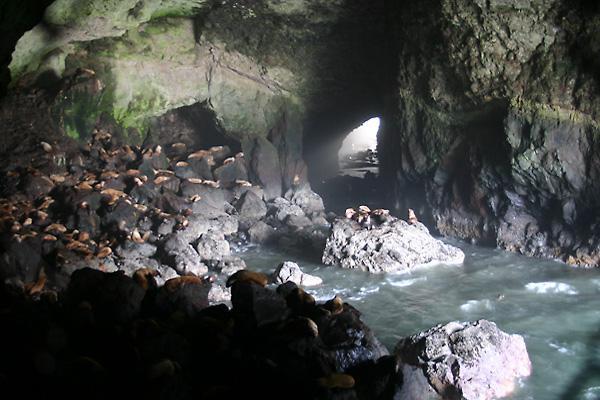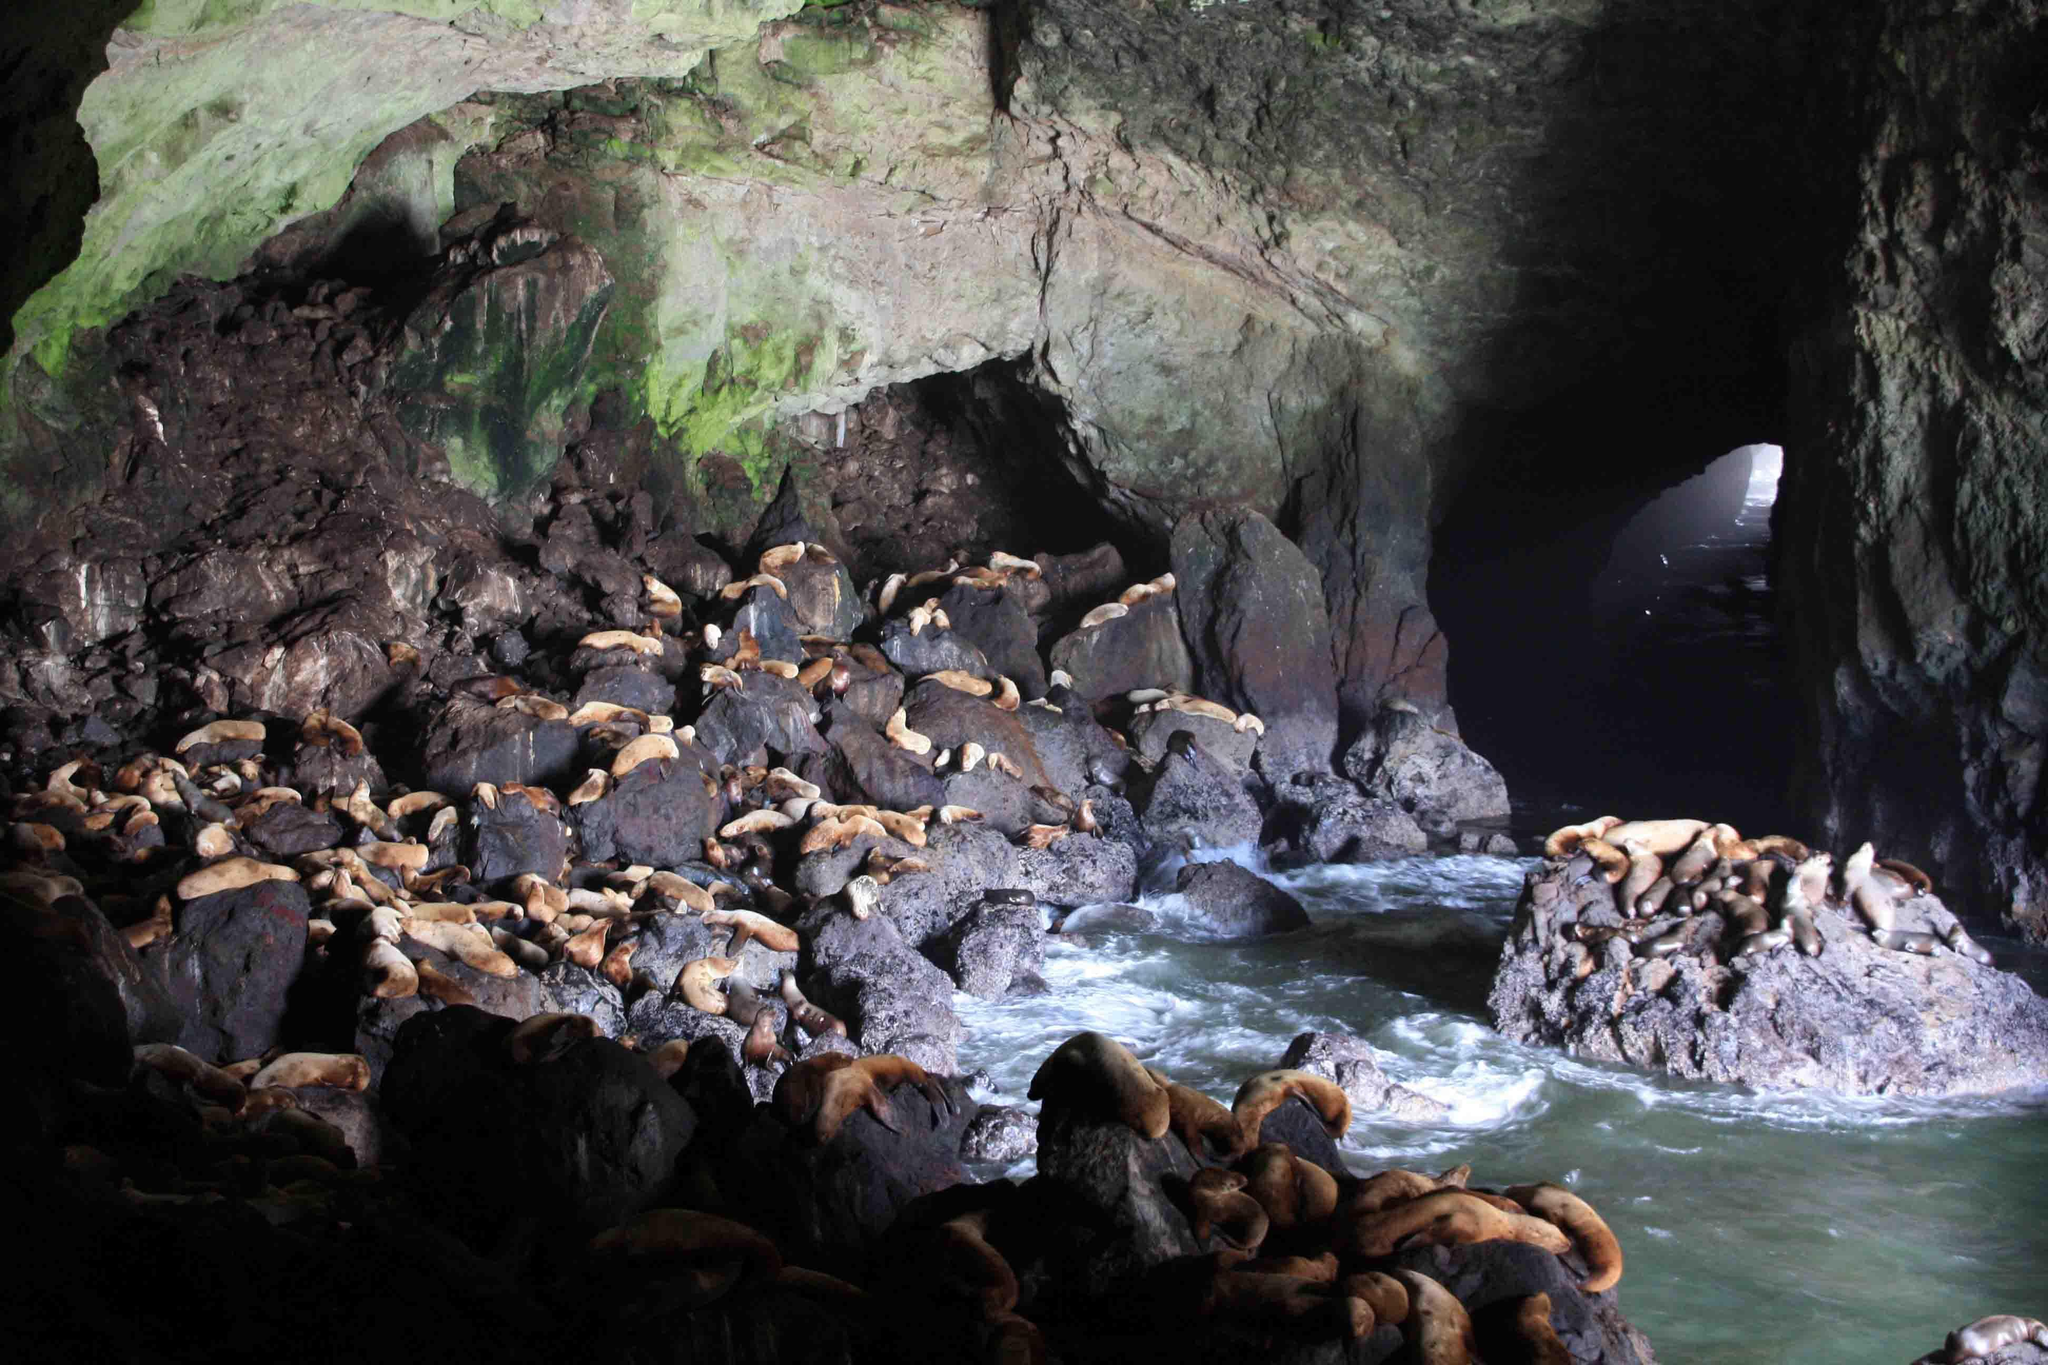The first image is the image on the left, the second image is the image on the right. For the images displayed, is the sentence "One or more of the photos shows sealions on a rock inside a cave." factually correct? Answer yes or no. Yes. The first image is the image on the left, the second image is the image on the right. Given the left and right images, does the statement "At least one image features a small island full of seals." hold true? Answer yes or no. Yes. 